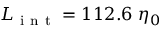Convert formula to latex. <formula><loc_0><loc_0><loc_500><loc_500>L _ { i n t } = 1 1 2 . 6 \ \eta _ { 0 }</formula> 